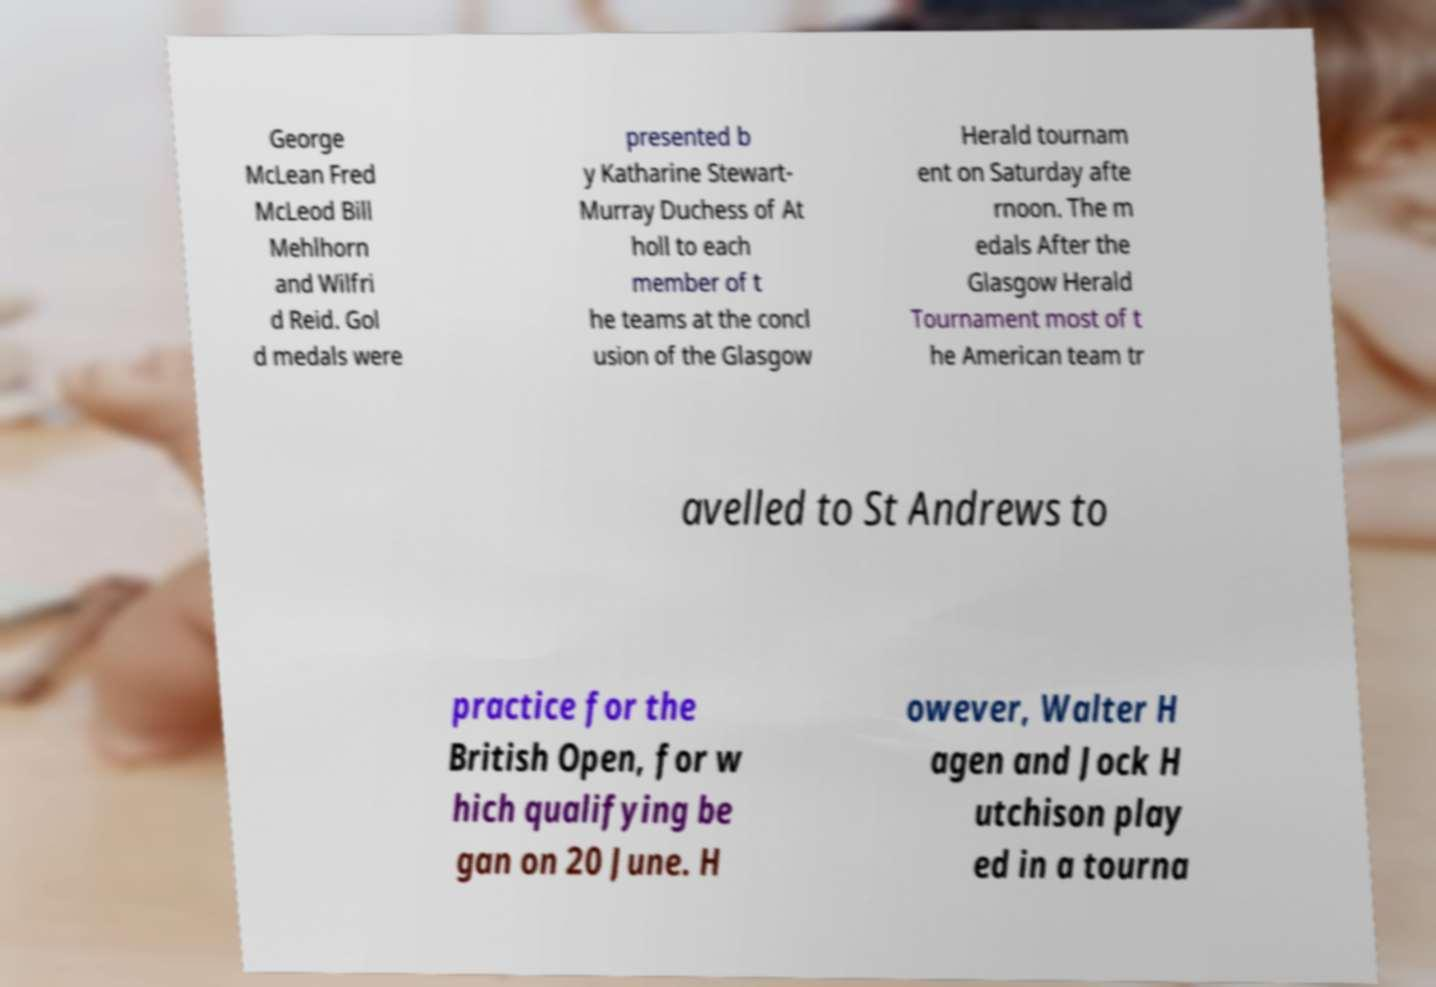Please identify and transcribe the text found in this image. George McLean Fred McLeod Bill Mehlhorn and Wilfri d Reid. Gol d medals were presented b y Katharine Stewart- Murray Duchess of At holl to each member of t he teams at the concl usion of the Glasgow Herald tournam ent on Saturday afte rnoon. The m edals After the Glasgow Herald Tournament most of t he American team tr avelled to St Andrews to practice for the British Open, for w hich qualifying be gan on 20 June. H owever, Walter H agen and Jock H utchison play ed in a tourna 